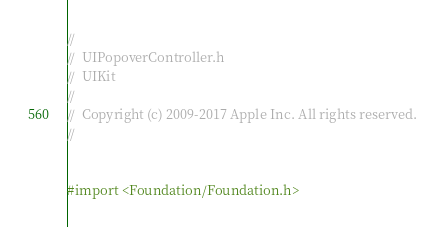Convert code to text. <code><loc_0><loc_0><loc_500><loc_500><_C_>//
//  UIPopoverController.h
//  UIKit
//
//  Copyright (c) 2009-2017 Apple Inc. All rights reserved.
//


#import <Foundation/Foundation.h></code> 